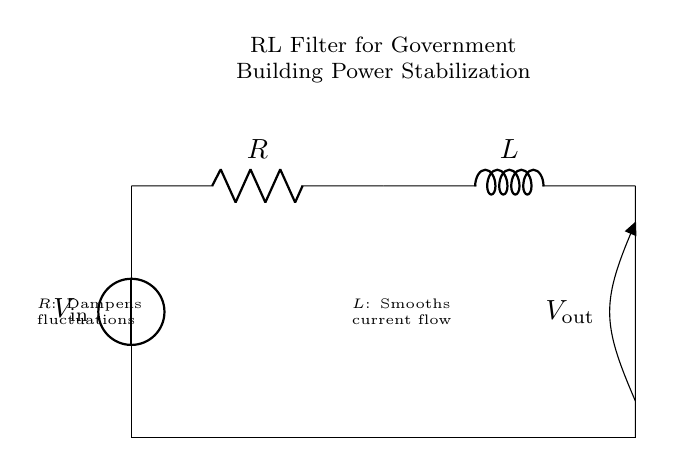What is the input voltage for this circuit? The input voltage, labeled as V in the diagram, is supplied by the voltage source at the top left corner of the circuit.
Answer: V What type of circuit is this? The circuit is classified as an RL filter circuit, which utilizes a resistor and an inductor to smooth out power fluctuations.
Answer: RL filter What does the resistor do in this circuit? The resistor, labeled as R, serves to dampen fluctuations in the current flowing through the circuit, providing stability to the output.
Answer: Dampens fluctuations What is the role of the inductor in this arrangement? The inductor, labeled as L, functions to smooth the current flow, allowing it to change less abruptly, which is crucial for stabilizing power in electrical systems.
Answer: Smooths current flow What is the output voltage denoted as? The output voltage is represented as V out, which is the voltage across the inductor and reflects the smoothed current output from the circuit.
Answer: V out What happens to current fluctuations when applying the RL filter? The RL filter effectively reduces rapid changes in current, thus minimizing fluctuations that could disrupt electrical systems in government buildings.
Answer: Reduces fluctuations 